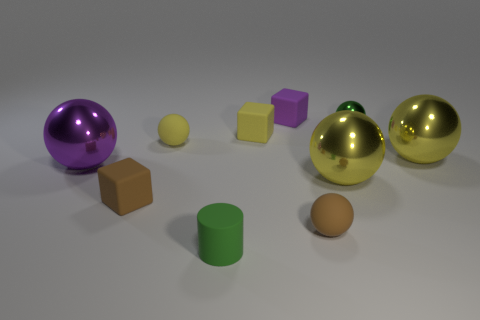Can you describe the objects in the center of the image? In the center of the image, you'll find three objects: a reflective golden sphere, a matte yellow sphere, smaller in size, and a cube with a hue that blends lavender and magenta. 